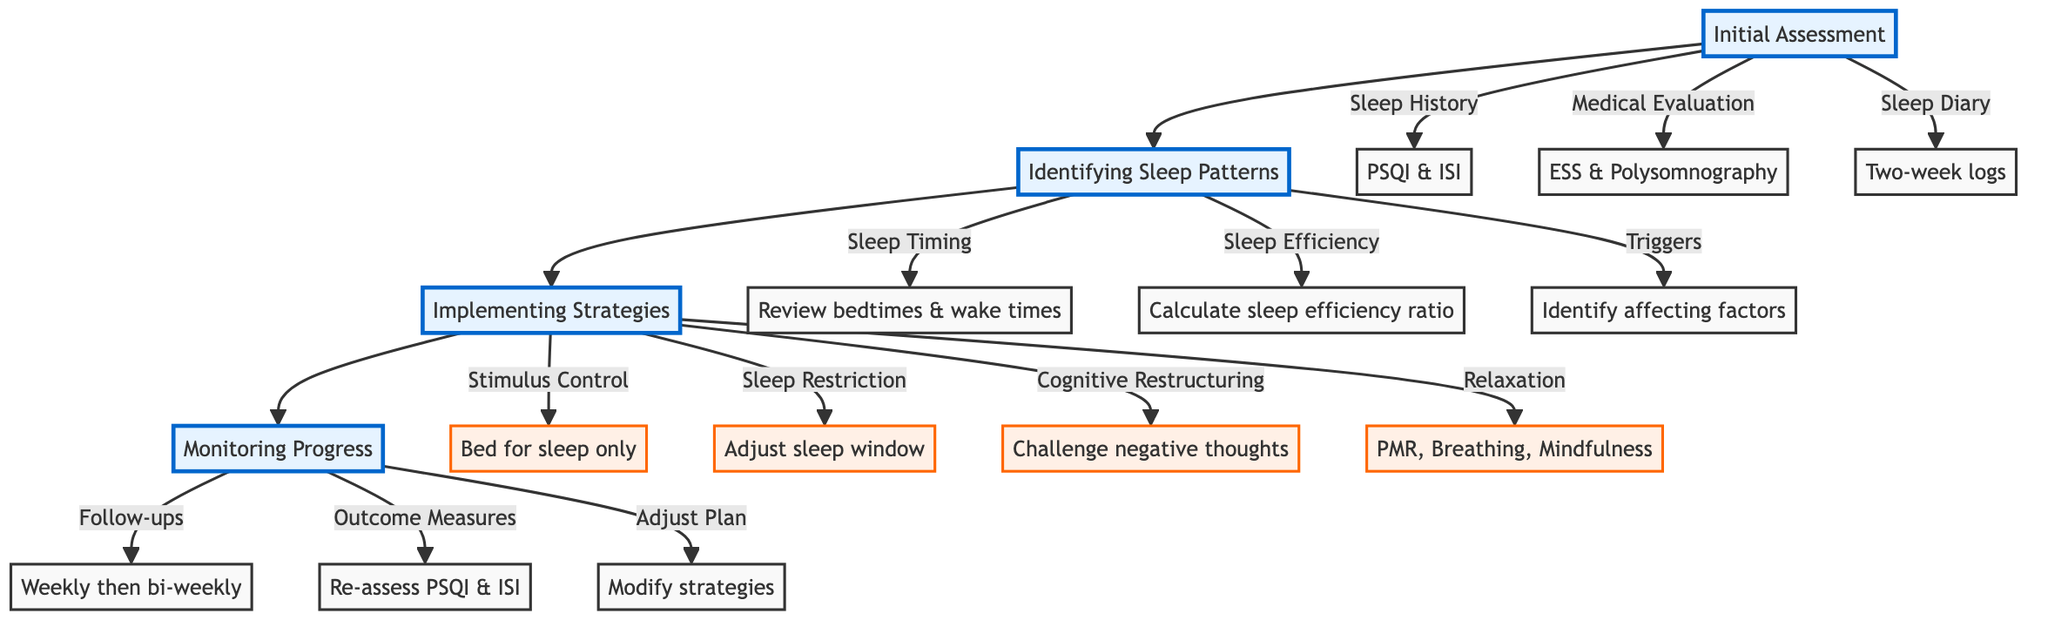What are the initial assessment components? The diagram lists three components under "Initial Assessment": Sleep History Interview, Medical Evaluation, and Sleep Diary. These are the primary elements needed to start the CBT process for insomnia.
Answer: Sleep History Interview, Medical Evaluation, Sleep Diary How many strategies are implemented for insomnia management? Under "Implementing Strategies," the diagram shows four distinct strategies: Stimulus Control, Sleep Restriction Therapy, Cognitive Restructuring, and Relaxation Techniques. Therefore, the total number of strategies is four.
Answer: 4 Which tools are used for the Medical Evaluation? The Medical Evaluation section specifies the tools used: Epworth Sleepiness Scale and Polysomnography if needed. These are the tools outlined in the pathway to assess medical conditions associated with insomnia.
Answer: Epworth Sleepiness Scale, Polysomnography What follows Identifying Sleep Patterns in the pathway? The flowchart indicates that "Identifying Sleep Patterns" directly leads to "Implementing Strategies." This shows the progression from analyzing sleep patterns to executing specific treatment strategies.
Answer: Implementing Strategies What is the purpose of Regular Follow-Ups? Regular Follow-Ups are meant to monitor the progress of the treatment. The diagram states that there are weekly check-ins during the first month and bi-weekly sessions afterward, which allows for ongoing assessment of the client's condition.
Answer: Monitor progress How does Sleep Restriction Therapy adjust sleep times? Sleep Restriction Therapy determines the average sleep time first, and then it adjusts the bed and wake times accordingly to consolidate sleep. This strategy involves proactive changes to the sleep schedule based on prior analysis.
Answer: Adjust bed and wake times Identify the tools used in Monitoring Progress. The diagram identifies three tools in "Monitoring Progress": Weekly check-ins for the first month, Bi-weekly sessions afterward, and Re-assessment using PSQI and ISI. These tools are vital for managing and adjusting treatment plans based on client feedback.
Answer: Weekly check-ins, Bi-weekly sessions, PSQI, ISI What is the first step in Cognitive Restructuring? The first step in Cognitive Restructuring is to identify negative sleep thoughts. This involves recognizing the harmful thoughts related to sleep that need to be addressed and altered.
Answer: Identify negative sleep thoughts What type of techniques are classified under Relaxation? The diagram outlines three types of relaxation techniques: Progressive Muscle Relaxation, Deep Breathing Exercises, and Mindfulness Meditation. These are specific methods employed to aid relaxation and promote better sleep.
Answer: Progressive Muscle Relaxation, Deep Breathing Exercises, Mindfulness Meditation 